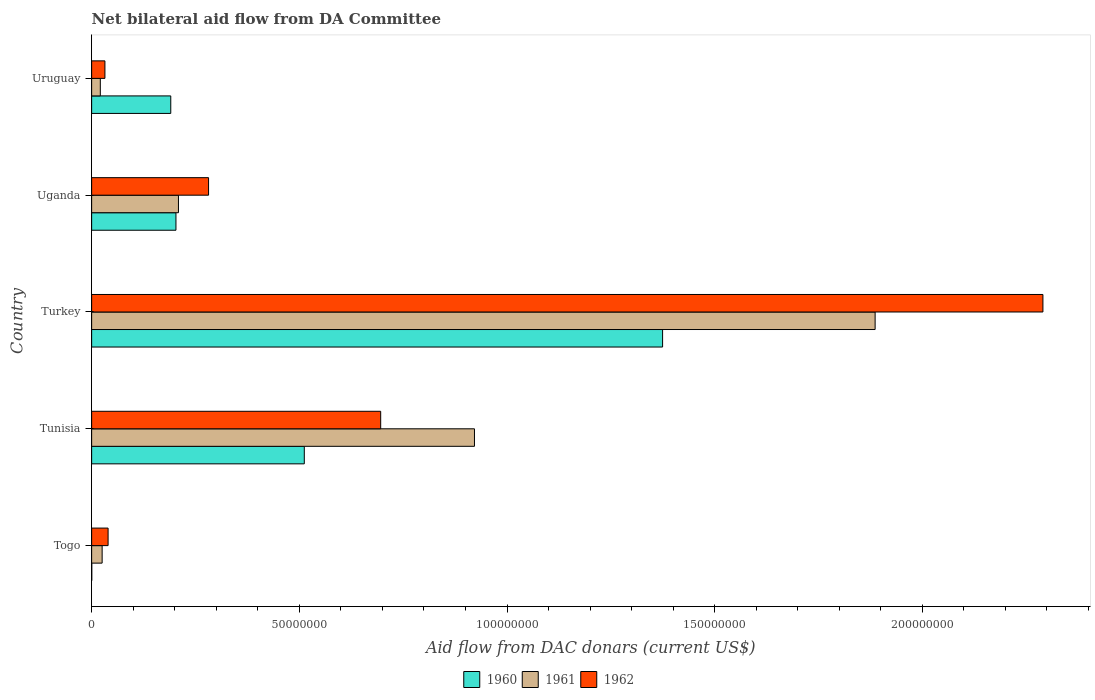Are the number of bars per tick equal to the number of legend labels?
Your answer should be compact. Yes. Are the number of bars on each tick of the Y-axis equal?
Provide a succinct answer. Yes. How many bars are there on the 2nd tick from the top?
Your response must be concise. 3. What is the label of the 3rd group of bars from the top?
Give a very brief answer. Turkey. In how many cases, is the number of bars for a given country not equal to the number of legend labels?
Ensure brevity in your answer.  0. What is the aid flow in in 1960 in Togo?
Make the answer very short. 3.00e+04. Across all countries, what is the maximum aid flow in in 1962?
Offer a very short reply. 2.29e+08. In which country was the aid flow in in 1961 minimum?
Your answer should be compact. Uruguay. What is the total aid flow in in 1961 in the graph?
Give a very brief answer. 3.06e+08. What is the difference between the aid flow in in 1962 in Tunisia and that in Turkey?
Provide a short and direct response. -1.59e+08. What is the difference between the aid flow in in 1960 in Tunisia and the aid flow in in 1961 in Togo?
Ensure brevity in your answer.  4.87e+07. What is the average aid flow in in 1960 per country?
Your response must be concise. 4.56e+07. What is the difference between the aid flow in in 1961 and aid flow in in 1960 in Turkey?
Give a very brief answer. 5.12e+07. In how many countries, is the aid flow in in 1962 greater than 60000000 US$?
Offer a very short reply. 2. What is the ratio of the aid flow in in 1961 in Togo to that in Uganda?
Give a very brief answer. 0.12. What is the difference between the highest and the second highest aid flow in in 1961?
Offer a terse response. 9.65e+07. What is the difference between the highest and the lowest aid flow in in 1960?
Ensure brevity in your answer.  1.37e+08. In how many countries, is the aid flow in in 1960 greater than the average aid flow in in 1960 taken over all countries?
Your response must be concise. 2. What does the 2nd bar from the top in Tunisia represents?
Ensure brevity in your answer.  1961. How many countries are there in the graph?
Offer a very short reply. 5. Does the graph contain grids?
Keep it short and to the point. No. How many legend labels are there?
Your answer should be very brief. 3. How are the legend labels stacked?
Your answer should be compact. Horizontal. What is the title of the graph?
Offer a very short reply. Net bilateral aid flow from DA Committee. What is the label or title of the X-axis?
Give a very brief answer. Aid flow from DAC donars (current US$). What is the Aid flow from DAC donars (current US$) in 1960 in Togo?
Ensure brevity in your answer.  3.00e+04. What is the Aid flow from DAC donars (current US$) of 1961 in Togo?
Offer a terse response. 2.53e+06. What is the Aid flow from DAC donars (current US$) in 1962 in Togo?
Offer a terse response. 3.96e+06. What is the Aid flow from DAC donars (current US$) in 1960 in Tunisia?
Your response must be concise. 5.12e+07. What is the Aid flow from DAC donars (current US$) in 1961 in Tunisia?
Offer a terse response. 9.22e+07. What is the Aid flow from DAC donars (current US$) in 1962 in Tunisia?
Provide a short and direct response. 6.96e+07. What is the Aid flow from DAC donars (current US$) of 1960 in Turkey?
Keep it short and to the point. 1.37e+08. What is the Aid flow from DAC donars (current US$) in 1961 in Turkey?
Give a very brief answer. 1.89e+08. What is the Aid flow from DAC donars (current US$) of 1962 in Turkey?
Provide a short and direct response. 2.29e+08. What is the Aid flow from DAC donars (current US$) in 1960 in Uganda?
Your answer should be very brief. 2.03e+07. What is the Aid flow from DAC donars (current US$) of 1961 in Uganda?
Ensure brevity in your answer.  2.09e+07. What is the Aid flow from DAC donars (current US$) in 1962 in Uganda?
Provide a short and direct response. 2.82e+07. What is the Aid flow from DAC donars (current US$) in 1960 in Uruguay?
Offer a terse response. 1.90e+07. What is the Aid flow from DAC donars (current US$) in 1961 in Uruguay?
Your answer should be very brief. 2.09e+06. What is the Aid flow from DAC donars (current US$) in 1962 in Uruguay?
Make the answer very short. 3.20e+06. Across all countries, what is the maximum Aid flow from DAC donars (current US$) in 1960?
Offer a terse response. 1.37e+08. Across all countries, what is the maximum Aid flow from DAC donars (current US$) in 1961?
Make the answer very short. 1.89e+08. Across all countries, what is the maximum Aid flow from DAC donars (current US$) of 1962?
Provide a succinct answer. 2.29e+08. Across all countries, what is the minimum Aid flow from DAC donars (current US$) of 1960?
Offer a terse response. 3.00e+04. Across all countries, what is the minimum Aid flow from DAC donars (current US$) in 1961?
Offer a very short reply. 2.09e+06. Across all countries, what is the minimum Aid flow from DAC donars (current US$) of 1962?
Ensure brevity in your answer.  3.20e+06. What is the total Aid flow from DAC donars (current US$) in 1960 in the graph?
Keep it short and to the point. 2.28e+08. What is the total Aid flow from DAC donars (current US$) in 1961 in the graph?
Provide a succinct answer. 3.06e+08. What is the total Aid flow from DAC donars (current US$) in 1962 in the graph?
Make the answer very short. 3.34e+08. What is the difference between the Aid flow from DAC donars (current US$) of 1960 in Togo and that in Tunisia?
Give a very brief answer. -5.12e+07. What is the difference between the Aid flow from DAC donars (current US$) in 1961 in Togo and that in Tunisia?
Give a very brief answer. -8.96e+07. What is the difference between the Aid flow from DAC donars (current US$) in 1962 in Togo and that in Tunisia?
Offer a very short reply. -6.56e+07. What is the difference between the Aid flow from DAC donars (current US$) of 1960 in Togo and that in Turkey?
Provide a succinct answer. -1.37e+08. What is the difference between the Aid flow from DAC donars (current US$) of 1961 in Togo and that in Turkey?
Your answer should be very brief. -1.86e+08. What is the difference between the Aid flow from DAC donars (current US$) in 1962 in Togo and that in Turkey?
Offer a very short reply. -2.25e+08. What is the difference between the Aid flow from DAC donars (current US$) of 1960 in Togo and that in Uganda?
Ensure brevity in your answer.  -2.03e+07. What is the difference between the Aid flow from DAC donars (current US$) in 1961 in Togo and that in Uganda?
Provide a succinct answer. -1.84e+07. What is the difference between the Aid flow from DAC donars (current US$) of 1962 in Togo and that in Uganda?
Your response must be concise. -2.42e+07. What is the difference between the Aid flow from DAC donars (current US$) of 1960 in Togo and that in Uruguay?
Your answer should be very brief. -1.90e+07. What is the difference between the Aid flow from DAC donars (current US$) in 1961 in Togo and that in Uruguay?
Your response must be concise. 4.40e+05. What is the difference between the Aid flow from DAC donars (current US$) of 1962 in Togo and that in Uruguay?
Make the answer very short. 7.60e+05. What is the difference between the Aid flow from DAC donars (current US$) in 1960 in Tunisia and that in Turkey?
Give a very brief answer. -8.63e+07. What is the difference between the Aid flow from DAC donars (current US$) of 1961 in Tunisia and that in Turkey?
Your answer should be compact. -9.65e+07. What is the difference between the Aid flow from DAC donars (current US$) of 1962 in Tunisia and that in Turkey?
Offer a terse response. -1.59e+08. What is the difference between the Aid flow from DAC donars (current US$) of 1960 in Tunisia and that in Uganda?
Your answer should be compact. 3.09e+07. What is the difference between the Aid flow from DAC donars (current US$) of 1961 in Tunisia and that in Uganda?
Offer a very short reply. 7.13e+07. What is the difference between the Aid flow from DAC donars (current US$) of 1962 in Tunisia and that in Uganda?
Ensure brevity in your answer.  4.14e+07. What is the difference between the Aid flow from DAC donars (current US$) in 1960 in Tunisia and that in Uruguay?
Your response must be concise. 3.22e+07. What is the difference between the Aid flow from DAC donars (current US$) in 1961 in Tunisia and that in Uruguay?
Your answer should be very brief. 9.01e+07. What is the difference between the Aid flow from DAC donars (current US$) in 1962 in Tunisia and that in Uruguay?
Make the answer very short. 6.64e+07. What is the difference between the Aid flow from DAC donars (current US$) in 1960 in Turkey and that in Uganda?
Your answer should be compact. 1.17e+08. What is the difference between the Aid flow from DAC donars (current US$) of 1961 in Turkey and that in Uganda?
Offer a terse response. 1.68e+08. What is the difference between the Aid flow from DAC donars (current US$) in 1962 in Turkey and that in Uganda?
Provide a succinct answer. 2.01e+08. What is the difference between the Aid flow from DAC donars (current US$) of 1960 in Turkey and that in Uruguay?
Keep it short and to the point. 1.18e+08. What is the difference between the Aid flow from DAC donars (current US$) in 1961 in Turkey and that in Uruguay?
Give a very brief answer. 1.87e+08. What is the difference between the Aid flow from DAC donars (current US$) in 1962 in Turkey and that in Uruguay?
Your response must be concise. 2.26e+08. What is the difference between the Aid flow from DAC donars (current US$) of 1960 in Uganda and that in Uruguay?
Give a very brief answer. 1.25e+06. What is the difference between the Aid flow from DAC donars (current US$) in 1961 in Uganda and that in Uruguay?
Ensure brevity in your answer.  1.88e+07. What is the difference between the Aid flow from DAC donars (current US$) in 1962 in Uganda and that in Uruguay?
Offer a very short reply. 2.50e+07. What is the difference between the Aid flow from DAC donars (current US$) of 1960 in Togo and the Aid flow from DAC donars (current US$) of 1961 in Tunisia?
Make the answer very short. -9.21e+07. What is the difference between the Aid flow from DAC donars (current US$) of 1960 in Togo and the Aid flow from DAC donars (current US$) of 1962 in Tunisia?
Offer a very short reply. -6.96e+07. What is the difference between the Aid flow from DAC donars (current US$) of 1961 in Togo and the Aid flow from DAC donars (current US$) of 1962 in Tunisia?
Offer a very short reply. -6.71e+07. What is the difference between the Aid flow from DAC donars (current US$) in 1960 in Togo and the Aid flow from DAC donars (current US$) in 1961 in Turkey?
Ensure brevity in your answer.  -1.89e+08. What is the difference between the Aid flow from DAC donars (current US$) of 1960 in Togo and the Aid flow from DAC donars (current US$) of 1962 in Turkey?
Provide a short and direct response. -2.29e+08. What is the difference between the Aid flow from DAC donars (current US$) in 1961 in Togo and the Aid flow from DAC donars (current US$) in 1962 in Turkey?
Your response must be concise. -2.26e+08. What is the difference between the Aid flow from DAC donars (current US$) in 1960 in Togo and the Aid flow from DAC donars (current US$) in 1961 in Uganda?
Your response must be concise. -2.09e+07. What is the difference between the Aid flow from DAC donars (current US$) of 1960 in Togo and the Aid flow from DAC donars (current US$) of 1962 in Uganda?
Make the answer very short. -2.81e+07. What is the difference between the Aid flow from DAC donars (current US$) of 1961 in Togo and the Aid flow from DAC donars (current US$) of 1962 in Uganda?
Your response must be concise. -2.56e+07. What is the difference between the Aid flow from DAC donars (current US$) in 1960 in Togo and the Aid flow from DAC donars (current US$) in 1961 in Uruguay?
Your response must be concise. -2.06e+06. What is the difference between the Aid flow from DAC donars (current US$) of 1960 in Togo and the Aid flow from DAC donars (current US$) of 1962 in Uruguay?
Your response must be concise. -3.17e+06. What is the difference between the Aid flow from DAC donars (current US$) of 1961 in Togo and the Aid flow from DAC donars (current US$) of 1962 in Uruguay?
Provide a short and direct response. -6.70e+05. What is the difference between the Aid flow from DAC donars (current US$) in 1960 in Tunisia and the Aid flow from DAC donars (current US$) in 1961 in Turkey?
Keep it short and to the point. -1.37e+08. What is the difference between the Aid flow from DAC donars (current US$) of 1960 in Tunisia and the Aid flow from DAC donars (current US$) of 1962 in Turkey?
Your answer should be very brief. -1.78e+08. What is the difference between the Aid flow from DAC donars (current US$) of 1961 in Tunisia and the Aid flow from DAC donars (current US$) of 1962 in Turkey?
Give a very brief answer. -1.37e+08. What is the difference between the Aid flow from DAC donars (current US$) of 1960 in Tunisia and the Aid flow from DAC donars (current US$) of 1961 in Uganda?
Your response must be concise. 3.03e+07. What is the difference between the Aid flow from DAC donars (current US$) in 1960 in Tunisia and the Aid flow from DAC donars (current US$) in 1962 in Uganda?
Your response must be concise. 2.30e+07. What is the difference between the Aid flow from DAC donars (current US$) in 1961 in Tunisia and the Aid flow from DAC donars (current US$) in 1962 in Uganda?
Your answer should be compact. 6.40e+07. What is the difference between the Aid flow from DAC donars (current US$) in 1960 in Tunisia and the Aid flow from DAC donars (current US$) in 1961 in Uruguay?
Keep it short and to the point. 4.91e+07. What is the difference between the Aid flow from DAC donars (current US$) in 1960 in Tunisia and the Aid flow from DAC donars (current US$) in 1962 in Uruguay?
Offer a very short reply. 4.80e+07. What is the difference between the Aid flow from DAC donars (current US$) in 1961 in Tunisia and the Aid flow from DAC donars (current US$) in 1962 in Uruguay?
Keep it short and to the point. 8.90e+07. What is the difference between the Aid flow from DAC donars (current US$) in 1960 in Turkey and the Aid flow from DAC donars (current US$) in 1961 in Uganda?
Your response must be concise. 1.17e+08. What is the difference between the Aid flow from DAC donars (current US$) in 1960 in Turkey and the Aid flow from DAC donars (current US$) in 1962 in Uganda?
Offer a very short reply. 1.09e+08. What is the difference between the Aid flow from DAC donars (current US$) in 1961 in Turkey and the Aid flow from DAC donars (current US$) in 1962 in Uganda?
Offer a terse response. 1.60e+08. What is the difference between the Aid flow from DAC donars (current US$) in 1960 in Turkey and the Aid flow from DAC donars (current US$) in 1961 in Uruguay?
Your answer should be compact. 1.35e+08. What is the difference between the Aid flow from DAC donars (current US$) of 1960 in Turkey and the Aid flow from DAC donars (current US$) of 1962 in Uruguay?
Your response must be concise. 1.34e+08. What is the difference between the Aid flow from DAC donars (current US$) in 1961 in Turkey and the Aid flow from DAC donars (current US$) in 1962 in Uruguay?
Make the answer very short. 1.85e+08. What is the difference between the Aid flow from DAC donars (current US$) in 1960 in Uganda and the Aid flow from DAC donars (current US$) in 1961 in Uruguay?
Give a very brief answer. 1.82e+07. What is the difference between the Aid flow from DAC donars (current US$) of 1960 in Uganda and the Aid flow from DAC donars (current US$) of 1962 in Uruguay?
Your response must be concise. 1.71e+07. What is the difference between the Aid flow from DAC donars (current US$) of 1961 in Uganda and the Aid flow from DAC donars (current US$) of 1962 in Uruguay?
Your answer should be compact. 1.77e+07. What is the average Aid flow from DAC donars (current US$) in 1960 per country?
Provide a short and direct response. 4.56e+07. What is the average Aid flow from DAC donars (current US$) of 1961 per country?
Keep it short and to the point. 6.13e+07. What is the average Aid flow from DAC donars (current US$) of 1962 per country?
Your response must be concise. 6.68e+07. What is the difference between the Aid flow from DAC donars (current US$) in 1960 and Aid flow from DAC donars (current US$) in 1961 in Togo?
Offer a terse response. -2.50e+06. What is the difference between the Aid flow from DAC donars (current US$) of 1960 and Aid flow from DAC donars (current US$) of 1962 in Togo?
Offer a very short reply. -3.93e+06. What is the difference between the Aid flow from DAC donars (current US$) in 1961 and Aid flow from DAC donars (current US$) in 1962 in Togo?
Your answer should be very brief. -1.43e+06. What is the difference between the Aid flow from DAC donars (current US$) in 1960 and Aid flow from DAC donars (current US$) in 1961 in Tunisia?
Your response must be concise. -4.10e+07. What is the difference between the Aid flow from DAC donars (current US$) of 1960 and Aid flow from DAC donars (current US$) of 1962 in Tunisia?
Provide a short and direct response. -1.84e+07. What is the difference between the Aid flow from DAC donars (current US$) in 1961 and Aid flow from DAC donars (current US$) in 1962 in Tunisia?
Ensure brevity in your answer.  2.26e+07. What is the difference between the Aid flow from DAC donars (current US$) in 1960 and Aid flow from DAC donars (current US$) in 1961 in Turkey?
Keep it short and to the point. -5.12e+07. What is the difference between the Aid flow from DAC donars (current US$) in 1960 and Aid flow from DAC donars (current US$) in 1962 in Turkey?
Keep it short and to the point. -9.16e+07. What is the difference between the Aid flow from DAC donars (current US$) of 1961 and Aid flow from DAC donars (current US$) of 1962 in Turkey?
Your response must be concise. -4.04e+07. What is the difference between the Aid flow from DAC donars (current US$) in 1960 and Aid flow from DAC donars (current US$) in 1961 in Uganda?
Your answer should be compact. -6.00e+05. What is the difference between the Aid flow from DAC donars (current US$) in 1960 and Aid flow from DAC donars (current US$) in 1962 in Uganda?
Ensure brevity in your answer.  -7.85e+06. What is the difference between the Aid flow from DAC donars (current US$) in 1961 and Aid flow from DAC donars (current US$) in 1962 in Uganda?
Your answer should be very brief. -7.25e+06. What is the difference between the Aid flow from DAC donars (current US$) in 1960 and Aid flow from DAC donars (current US$) in 1961 in Uruguay?
Your answer should be compact. 1.70e+07. What is the difference between the Aid flow from DAC donars (current US$) in 1960 and Aid flow from DAC donars (current US$) in 1962 in Uruguay?
Offer a terse response. 1.58e+07. What is the difference between the Aid flow from DAC donars (current US$) in 1961 and Aid flow from DAC donars (current US$) in 1962 in Uruguay?
Make the answer very short. -1.11e+06. What is the ratio of the Aid flow from DAC donars (current US$) of 1960 in Togo to that in Tunisia?
Provide a succinct answer. 0. What is the ratio of the Aid flow from DAC donars (current US$) in 1961 in Togo to that in Tunisia?
Your answer should be compact. 0.03. What is the ratio of the Aid flow from DAC donars (current US$) in 1962 in Togo to that in Tunisia?
Keep it short and to the point. 0.06. What is the ratio of the Aid flow from DAC donars (current US$) in 1961 in Togo to that in Turkey?
Your response must be concise. 0.01. What is the ratio of the Aid flow from DAC donars (current US$) of 1962 in Togo to that in Turkey?
Offer a very short reply. 0.02. What is the ratio of the Aid flow from DAC donars (current US$) of 1960 in Togo to that in Uganda?
Provide a short and direct response. 0. What is the ratio of the Aid flow from DAC donars (current US$) of 1961 in Togo to that in Uganda?
Provide a short and direct response. 0.12. What is the ratio of the Aid flow from DAC donars (current US$) in 1962 in Togo to that in Uganda?
Offer a terse response. 0.14. What is the ratio of the Aid flow from DAC donars (current US$) in 1960 in Togo to that in Uruguay?
Offer a very short reply. 0. What is the ratio of the Aid flow from DAC donars (current US$) in 1961 in Togo to that in Uruguay?
Your response must be concise. 1.21. What is the ratio of the Aid flow from DAC donars (current US$) of 1962 in Togo to that in Uruguay?
Provide a succinct answer. 1.24. What is the ratio of the Aid flow from DAC donars (current US$) of 1960 in Tunisia to that in Turkey?
Ensure brevity in your answer.  0.37. What is the ratio of the Aid flow from DAC donars (current US$) of 1961 in Tunisia to that in Turkey?
Offer a terse response. 0.49. What is the ratio of the Aid flow from DAC donars (current US$) in 1962 in Tunisia to that in Turkey?
Provide a succinct answer. 0.3. What is the ratio of the Aid flow from DAC donars (current US$) of 1960 in Tunisia to that in Uganda?
Your answer should be compact. 2.52. What is the ratio of the Aid flow from DAC donars (current US$) of 1961 in Tunisia to that in Uganda?
Offer a terse response. 4.41. What is the ratio of the Aid flow from DAC donars (current US$) of 1962 in Tunisia to that in Uganda?
Offer a very short reply. 2.47. What is the ratio of the Aid flow from DAC donars (current US$) in 1960 in Tunisia to that in Uruguay?
Keep it short and to the point. 2.69. What is the ratio of the Aid flow from DAC donars (current US$) of 1961 in Tunisia to that in Uruguay?
Your response must be concise. 44.1. What is the ratio of the Aid flow from DAC donars (current US$) in 1962 in Tunisia to that in Uruguay?
Ensure brevity in your answer.  21.75. What is the ratio of the Aid flow from DAC donars (current US$) in 1960 in Turkey to that in Uganda?
Your answer should be compact. 6.77. What is the ratio of the Aid flow from DAC donars (current US$) in 1961 in Turkey to that in Uganda?
Your answer should be compact. 9.03. What is the ratio of the Aid flow from DAC donars (current US$) of 1962 in Turkey to that in Uganda?
Keep it short and to the point. 8.14. What is the ratio of the Aid flow from DAC donars (current US$) of 1960 in Turkey to that in Uruguay?
Offer a very short reply. 7.22. What is the ratio of the Aid flow from DAC donars (current US$) of 1961 in Turkey to that in Uruguay?
Offer a very short reply. 90.25. What is the ratio of the Aid flow from DAC donars (current US$) of 1962 in Turkey to that in Uruguay?
Provide a short and direct response. 71.57. What is the ratio of the Aid flow from DAC donars (current US$) in 1960 in Uganda to that in Uruguay?
Give a very brief answer. 1.07. What is the ratio of the Aid flow from DAC donars (current US$) of 1962 in Uganda to that in Uruguay?
Offer a very short reply. 8.8. What is the difference between the highest and the second highest Aid flow from DAC donars (current US$) in 1960?
Give a very brief answer. 8.63e+07. What is the difference between the highest and the second highest Aid flow from DAC donars (current US$) in 1961?
Offer a terse response. 9.65e+07. What is the difference between the highest and the second highest Aid flow from DAC donars (current US$) in 1962?
Give a very brief answer. 1.59e+08. What is the difference between the highest and the lowest Aid flow from DAC donars (current US$) in 1960?
Keep it short and to the point. 1.37e+08. What is the difference between the highest and the lowest Aid flow from DAC donars (current US$) of 1961?
Provide a succinct answer. 1.87e+08. What is the difference between the highest and the lowest Aid flow from DAC donars (current US$) in 1962?
Provide a short and direct response. 2.26e+08. 